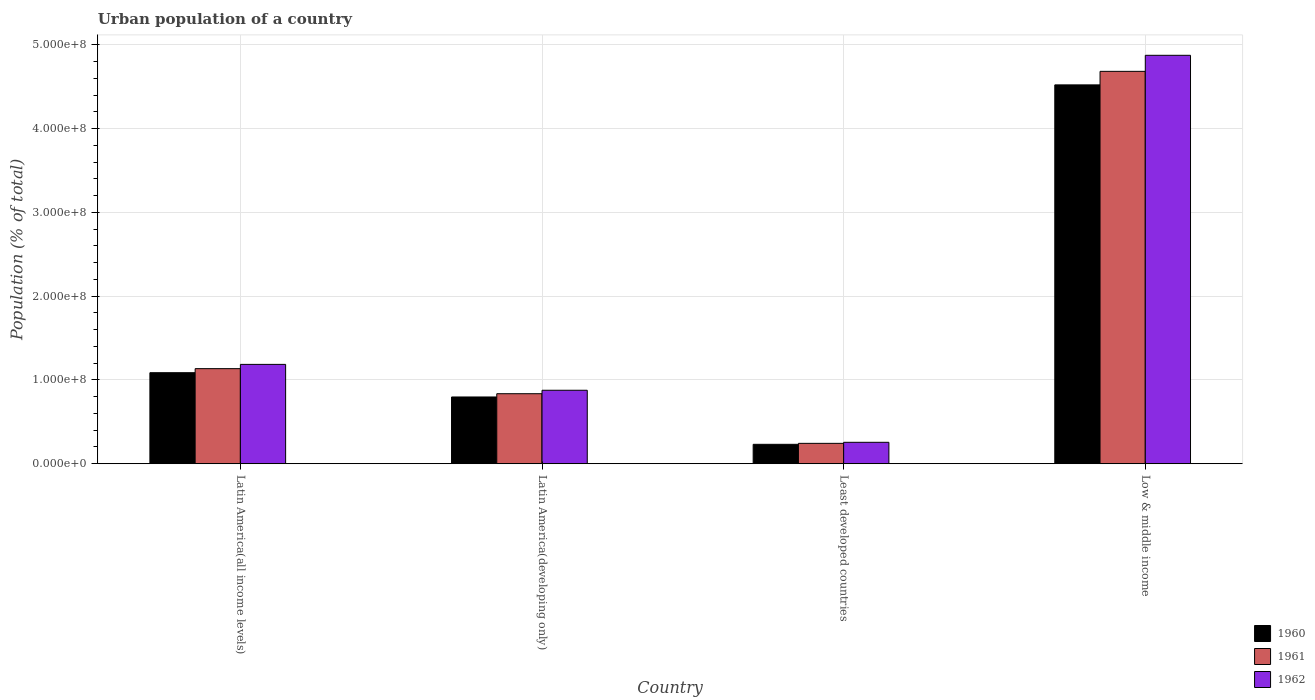How many different coloured bars are there?
Your answer should be compact. 3. How many groups of bars are there?
Your response must be concise. 4. How many bars are there on the 1st tick from the left?
Make the answer very short. 3. What is the label of the 1st group of bars from the left?
Your answer should be very brief. Latin America(all income levels). What is the urban population in 1962 in Low & middle income?
Keep it short and to the point. 4.88e+08. Across all countries, what is the maximum urban population in 1961?
Offer a terse response. 4.69e+08. Across all countries, what is the minimum urban population in 1961?
Ensure brevity in your answer.  2.43e+07. In which country was the urban population in 1960 maximum?
Provide a short and direct response. Low & middle income. In which country was the urban population in 1962 minimum?
Your answer should be very brief. Least developed countries. What is the total urban population in 1960 in the graph?
Provide a succinct answer. 6.64e+08. What is the difference between the urban population in 1961 in Latin America(developing only) and that in Low & middle income?
Your response must be concise. -3.85e+08. What is the difference between the urban population in 1960 in Low & middle income and the urban population in 1961 in Latin America(developing only)?
Provide a succinct answer. 3.69e+08. What is the average urban population in 1962 per country?
Make the answer very short. 1.80e+08. What is the difference between the urban population of/in 1961 and urban population of/in 1960 in Least developed countries?
Make the answer very short. 1.15e+06. In how many countries, is the urban population in 1961 greater than 320000000 %?
Provide a succinct answer. 1. What is the ratio of the urban population in 1961 in Latin America(all income levels) to that in Low & middle income?
Your answer should be very brief. 0.24. Is the urban population in 1961 in Latin America(developing only) less than that in Least developed countries?
Provide a succinct answer. No. Is the difference between the urban population in 1961 in Latin America(developing only) and Least developed countries greater than the difference between the urban population in 1960 in Latin America(developing only) and Least developed countries?
Your answer should be compact. Yes. What is the difference between the highest and the second highest urban population in 1962?
Your answer should be compact. 3.09e+07. What is the difference between the highest and the lowest urban population in 1962?
Ensure brevity in your answer.  4.62e+08. What does the 1st bar from the right in Latin America(all income levels) represents?
Your answer should be compact. 1962. Is it the case that in every country, the sum of the urban population in 1962 and urban population in 1961 is greater than the urban population in 1960?
Give a very brief answer. Yes. Are all the bars in the graph horizontal?
Offer a very short reply. No. How many countries are there in the graph?
Make the answer very short. 4. What is the difference between two consecutive major ticks on the Y-axis?
Provide a short and direct response. 1.00e+08. Does the graph contain any zero values?
Ensure brevity in your answer.  No. Does the graph contain grids?
Make the answer very short. Yes. How are the legend labels stacked?
Your response must be concise. Vertical. What is the title of the graph?
Your answer should be compact. Urban population of a country. Does "1966" appear as one of the legend labels in the graph?
Your answer should be compact. No. What is the label or title of the Y-axis?
Make the answer very short. Population (% of total). What is the Population (% of total) in 1960 in Latin America(all income levels)?
Your answer should be very brief. 1.09e+08. What is the Population (% of total) of 1961 in Latin America(all income levels)?
Provide a succinct answer. 1.14e+08. What is the Population (% of total) in 1962 in Latin America(all income levels)?
Your answer should be very brief. 1.19e+08. What is the Population (% of total) in 1960 in Latin America(developing only)?
Ensure brevity in your answer.  7.97e+07. What is the Population (% of total) in 1961 in Latin America(developing only)?
Offer a terse response. 8.36e+07. What is the Population (% of total) in 1962 in Latin America(developing only)?
Your answer should be compact. 8.77e+07. What is the Population (% of total) of 1960 in Least developed countries?
Make the answer very short. 2.32e+07. What is the Population (% of total) in 1961 in Least developed countries?
Keep it short and to the point. 2.43e+07. What is the Population (% of total) of 1962 in Least developed countries?
Make the answer very short. 2.56e+07. What is the Population (% of total) of 1960 in Low & middle income?
Your answer should be compact. 4.52e+08. What is the Population (% of total) of 1961 in Low & middle income?
Keep it short and to the point. 4.69e+08. What is the Population (% of total) of 1962 in Low & middle income?
Keep it short and to the point. 4.88e+08. Across all countries, what is the maximum Population (% of total) in 1960?
Offer a very short reply. 4.52e+08. Across all countries, what is the maximum Population (% of total) in 1961?
Your response must be concise. 4.69e+08. Across all countries, what is the maximum Population (% of total) of 1962?
Ensure brevity in your answer.  4.88e+08. Across all countries, what is the minimum Population (% of total) in 1960?
Provide a succinct answer. 2.32e+07. Across all countries, what is the minimum Population (% of total) of 1961?
Provide a succinct answer. 2.43e+07. Across all countries, what is the minimum Population (% of total) of 1962?
Your answer should be compact. 2.56e+07. What is the total Population (% of total) in 1960 in the graph?
Ensure brevity in your answer.  6.64e+08. What is the total Population (% of total) of 1961 in the graph?
Your response must be concise. 6.90e+08. What is the total Population (% of total) in 1962 in the graph?
Your answer should be compact. 7.20e+08. What is the difference between the Population (% of total) in 1960 in Latin America(all income levels) and that in Latin America(developing only)?
Offer a terse response. 2.90e+07. What is the difference between the Population (% of total) of 1961 in Latin America(all income levels) and that in Latin America(developing only)?
Provide a short and direct response. 2.99e+07. What is the difference between the Population (% of total) in 1962 in Latin America(all income levels) and that in Latin America(developing only)?
Your answer should be very brief. 3.09e+07. What is the difference between the Population (% of total) in 1960 in Latin America(all income levels) and that in Least developed countries?
Make the answer very short. 8.55e+07. What is the difference between the Population (% of total) of 1961 in Latin America(all income levels) and that in Least developed countries?
Ensure brevity in your answer.  8.92e+07. What is the difference between the Population (% of total) of 1962 in Latin America(all income levels) and that in Least developed countries?
Your answer should be compact. 9.30e+07. What is the difference between the Population (% of total) of 1960 in Latin America(all income levels) and that in Low & middle income?
Keep it short and to the point. -3.44e+08. What is the difference between the Population (% of total) in 1961 in Latin America(all income levels) and that in Low & middle income?
Your response must be concise. -3.55e+08. What is the difference between the Population (% of total) in 1962 in Latin America(all income levels) and that in Low & middle income?
Keep it short and to the point. -3.69e+08. What is the difference between the Population (% of total) of 1960 in Latin America(developing only) and that in Least developed countries?
Make the answer very short. 5.65e+07. What is the difference between the Population (% of total) of 1961 in Latin America(developing only) and that in Least developed countries?
Your answer should be compact. 5.93e+07. What is the difference between the Population (% of total) in 1962 in Latin America(developing only) and that in Least developed countries?
Make the answer very short. 6.22e+07. What is the difference between the Population (% of total) of 1960 in Latin America(developing only) and that in Low & middle income?
Provide a short and direct response. -3.73e+08. What is the difference between the Population (% of total) in 1961 in Latin America(developing only) and that in Low & middle income?
Your response must be concise. -3.85e+08. What is the difference between the Population (% of total) of 1962 in Latin America(developing only) and that in Low & middle income?
Offer a very short reply. -4.00e+08. What is the difference between the Population (% of total) in 1960 in Least developed countries and that in Low & middle income?
Offer a very short reply. -4.29e+08. What is the difference between the Population (% of total) of 1961 in Least developed countries and that in Low & middle income?
Provide a succinct answer. -4.44e+08. What is the difference between the Population (% of total) in 1962 in Least developed countries and that in Low & middle income?
Provide a succinct answer. -4.62e+08. What is the difference between the Population (% of total) of 1960 in Latin America(all income levels) and the Population (% of total) of 1961 in Latin America(developing only)?
Offer a very short reply. 2.51e+07. What is the difference between the Population (% of total) of 1960 in Latin America(all income levels) and the Population (% of total) of 1962 in Latin America(developing only)?
Your answer should be compact. 2.10e+07. What is the difference between the Population (% of total) in 1961 in Latin America(all income levels) and the Population (% of total) in 1962 in Latin America(developing only)?
Your answer should be very brief. 2.58e+07. What is the difference between the Population (% of total) in 1960 in Latin America(all income levels) and the Population (% of total) in 1961 in Least developed countries?
Offer a very short reply. 8.44e+07. What is the difference between the Population (% of total) of 1960 in Latin America(all income levels) and the Population (% of total) of 1962 in Least developed countries?
Ensure brevity in your answer.  8.31e+07. What is the difference between the Population (% of total) in 1961 in Latin America(all income levels) and the Population (% of total) in 1962 in Least developed countries?
Give a very brief answer. 8.80e+07. What is the difference between the Population (% of total) of 1960 in Latin America(all income levels) and the Population (% of total) of 1961 in Low & middle income?
Your answer should be compact. -3.60e+08. What is the difference between the Population (% of total) in 1960 in Latin America(all income levels) and the Population (% of total) in 1962 in Low & middle income?
Give a very brief answer. -3.79e+08. What is the difference between the Population (% of total) of 1961 in Latin America(all income levels) and the Population (% of total) of 1962 in Low & middle income?
Offer a terse response. -3.74e+08. What is the difference between the Population (% of total) of 1960 in Latin America(developing only) and the Population (% of total) of 1961 in Least developed countries?
Make the answer very short. 5.54e+07. What is the difference between the Population (% of total) of 1960 in Latin America(developing only) and the Population (% of total) of 1962 in Least developed countries?
Keep it short and to the point. 5.41e+07. What is the difference between the Population (% of total) of 1961 in Latin America(developing only) and the Population (% of total) of 1962 in Least developed countries?
Offer a terse response. 5.80e+07. What is the difference between the Population (% of total) of 1960 in Latin America(developing only) and the Population (% of total) of 1961 in Low & middle income?
Your response must be concise. -3.89e+08. What is the difference between the Population (% of total) of 1960 in Latin America(developing only) and the Population (% of total) of 1962 in Low & middle income?
Make the answer very short. -4.08e+08. What is the difference between the Population (% of total) in 1961 in Latin America(developing only) and the Population (% of total) in 1962 in Low & middle income?
Give a very brief answer. -4.04e+08. What is the difference between the Population (% of total) in 1960 in Least developed countries and the Population (% of total) in 1961 in Low & middle income?
Your answer should be compact. -4.45e+08. What is the difference between the Population (% of total) of 1960 in Least developed countries and the Population (% of total) of 1962 in Low & middle income?
Give a very brief answer. -4.64e+08. What is the difference between the Population (% of total) in 1961 in Least developed countries and the Population (% of total) in 1962 in Low & middle income?
Offer a terse response. -4.63e+08. What is the average Population (% of total) of 1960 per country?
Your response must be concise. 1.66e+08. What is the average Population (% of total) of 1961 per country?
Your response must be concise. 1.72e+08. What is the average Population (% of total) of 1962 per country?
Offer a very short reply. 1.80e+08. What is the difference between the Population (% of total) in 1960 and Population (% of total) in 1961 in Latin America(all income levels)?
Ensure brevity in your answer.  -4.84e+06. What is the difference between the Population (% of total) in 1960 and Population (% of total) in 1962 in Latin America(all income levels)?
Ensure brevity in your answer.  -9.92e+06. What is the difference between the Population (% of total) in 1961 and Population (% of total) in 1962 in Latin America(all income levels)?
Offer a very short reply. -5.08e+06. What is the difference between the Population (% of total) in 1960 and Population (% of total) in 1961 in Latin America(developing only)?
Keep it short and to the point. -3.89e+06. What is the difference between the Population (% of total) in 1960 and Population (% of total) in 1962 in Latin America(developing only)?
Provide a succinct answer. -8.03e+06. What is the difference between the Population (% of total) in 1961 and Population (% of total) in 1962 in Latin America(developing only)?
Offer a terse response. -4.13e+06. What is the difference between the Population (% of total) of 1960 and Population (% of total) of 1961 in Least developed countries?
Offer a terse response. -1.15e+06. What is the difference between the Population (% of total) of 1960 and Population (% of total) of 1962 in Least developed countries?
Provide a short and direct response. -2.40e+06. What is the difference between the Population (% of total) in 1961 and Population (% of total) in 1962 in Least developed countries?
Your response must be concise. -1.25e+06. What is the difference between the Population (% of total) in 1960 and Population (% of total) in 1961 in Low & middle income?
Offer a terse response. -1.62e+07. What is the difference between the Population (% of total) of 1960 and Population (% of total) of 1962 in Low & middle income?
Your answer should be very brief. -3.53e+07. What is the difference between the Population (% of total) in 1961 and Population (% of total) in 1962 in Low & middle income?
Make the answer very short. -1.92e+07. What is the ratio of the Population (% of total) of 1960 in Latin America(all income levels) to that in Latin America(developing only)?
Your answer should be very brief. 1.36. What is the ratio of the Population (% of total) of 1961 in Latin America(all income levels) to that in Latin America(developing only)?
Your answer should be compact. 1.36. What is the ratio of the Population (% of total) of 1962 in Latin America(all income levels) to that in Latin America(developing only)?
Your response must be concise. 1.35. What is the ratio of the Population (% of total) of 1960 in Latin America(all income levels) to that in Least developed countries?
Your answer should be compact. 4.69. What is the ratio of the Population (% of total) in 1961 in Latin America(all income levels) to that in Least developed countries?
Your response must be concise. 4.67. What is the ratio of the Population (% of total) in 1962 in Latin America(all income levels) to that in Least developed countries?
Your answer should be very brief. 4.64. What is the ratio of the Population (% of total) in 1960 in Latin America(all income levels) to that in Low & middle income?
Keep it short and to the point. 0.24. What is the ratio of the Population (% of total) in 1961 in Latin America(all income levels) to that in Low & middle income?
Your answer should be very brief. 0.24. What is the ratio of the Population (% of total) of 1962 in Latin America(all income levels) to that in Low & middle income?
Keep it short and to the point. 0.24. What is the ratio of the Population (% of total) of 1960 in Latin America(developing only) to that in Least developed countries?
Give a very brief answer. 3.44. What is the ratio of the Population (% of total) of 1961 in Latin America(developing only) to that in Least developed countries?
Provide a short and direct response. 3.44. What is the ratio of the Population (% of total) in 1962 in Latin America(developing only) to that in Least developed countries?
Ensure brevity in your answer.  3.43. What is the ratio of the Population (% of total) of 1960 in Latin America(developing only) to that in Low & middle income?
Make the answer very short. 0.18. What is the ratio of the Population (% of total) in 1961 in Latin America(developing only) to that in Low & middle income?
Your response must be concise. 0.18. What is the ratio of the Population (% of total) in 1962 in Latin America(developing only) to that in Low & middle income?
Give a very brief answer. 0.18. What is the ratio of the Population (% of total) of 1960 in Least developed countries to that in Low & middle income?
Your response must be concise. 0.05. What is the ratio of the Population (% of total) in 1961 in Least developed countries to that in Low & middle income?
Keep it short and to the point. 0.05. What is the ratio of the Population (% of total) in 1962 in Least developed countries to that in Low & middle income?
Make the answer very short. 0.05. What is the difference between the highest and the second highest Population (% of total) of 1960?
Keep it short and to the point. 3.44e+08. What is the difference between the highest and the second highest Population (% of total) of 1961?
Offer a very short reply. 3.55e+08. What is the difference between the highest and the second highest Population (% of total) in 1962?
Provide a short and direct response. 3.69e+08. What is the difference between the highest and the lowest Population (% of total) of 1960?
Offer a very short reply. 4.29e+08. What is the difference between the highest and the lowest Population (% of total) of 1961?
Ensure brevity in your answer.  4.44e+08. What is the difference between the highest and the lowest Population (% of total) in 1962?
Provide a short and direct response. 4.62e+08. 